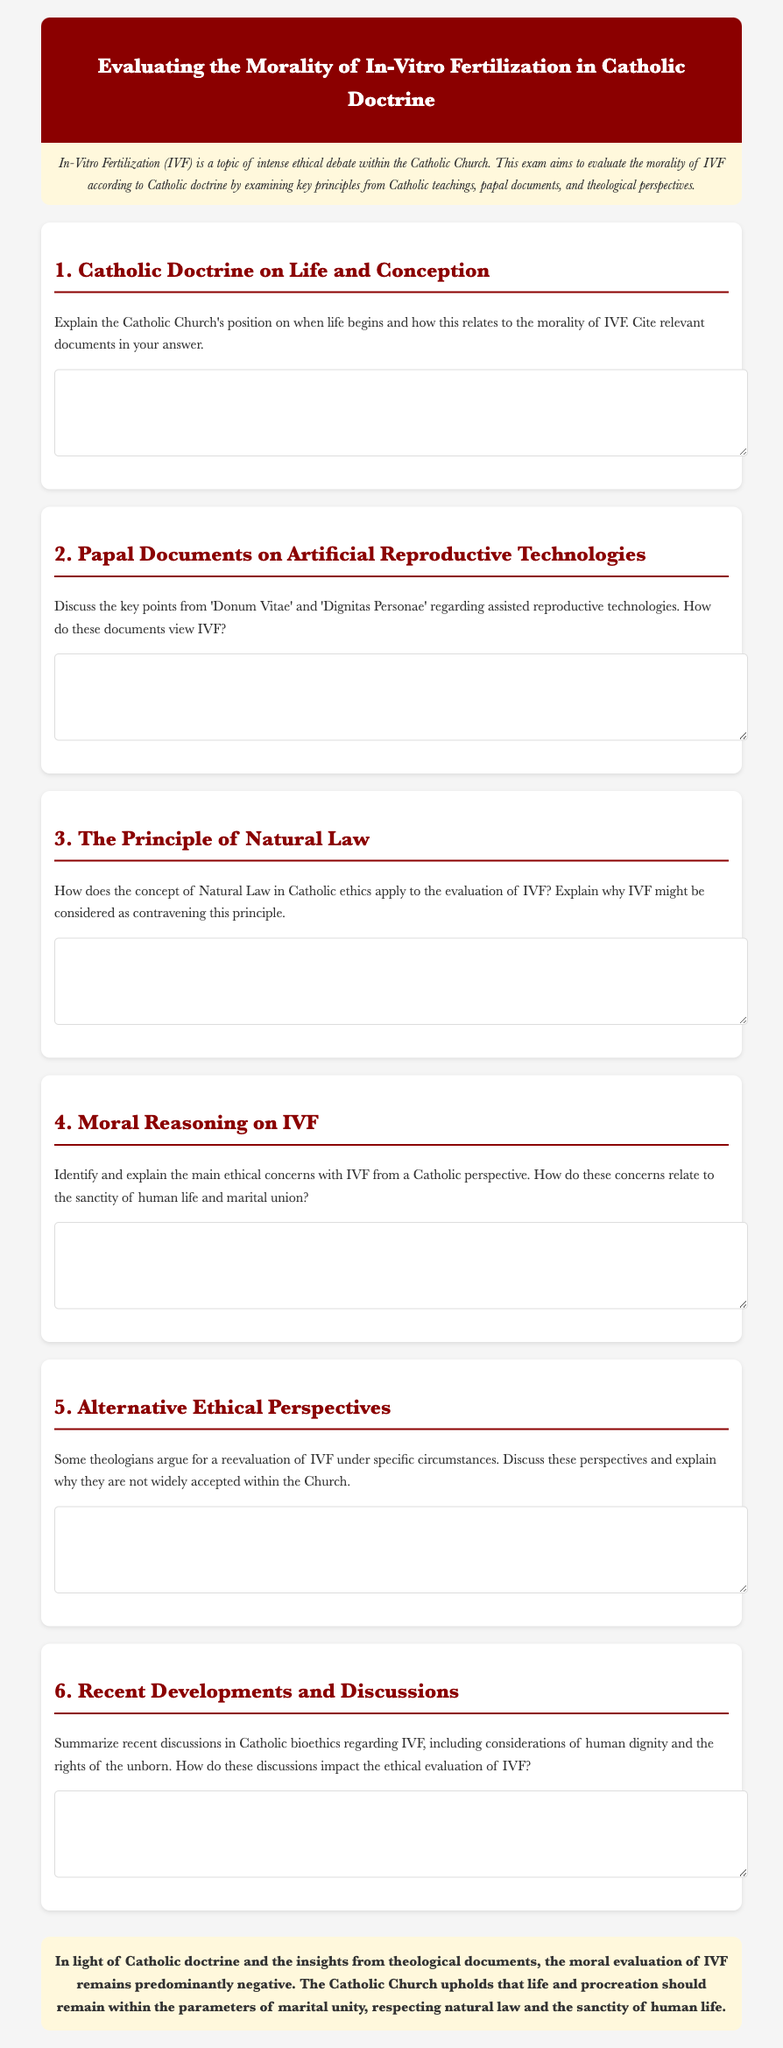What is the title of the document? The title is found in the header of the document.
Answer: Evaluating the Morality of In-Vitro Fertilization in Catholic Doctrine What does the introduction emphasize? The introduction provides context about the subject matter and its significance.
Answer: Ethical debate Which document is cited in the section about artificial reproductive technologies? This question refers to the documents highlighted in the second section of the exam.
Answer: Donum Vitae What principle does the third section relate to? The section discusses a fundamental concept in Catholic ethics.
Answer: Natural Law How many sections are in the document? The total number of sections, including the conclusion, is counted.
Answer: 7 What color is the header of the document? The header color is mentioned in the styling of the document.
Answer: Dark red What does the conclusion summarize? The conclusion encapsulates the overall findings of the document.
Answer: Moral evaluation of IVF In which section would you find ethical concerns related to IVF? This question refers to the organization of the document.
Answer: Section 4 What type of technology is being evaluated? This question focuses on the specific type of reproductive technology discussed.
Answer: In-Vitro Fertilization (IVF) 